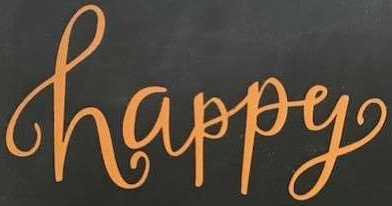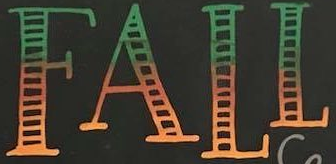Read the text content from these images in order, separated by a semicolon. happy; FALL 